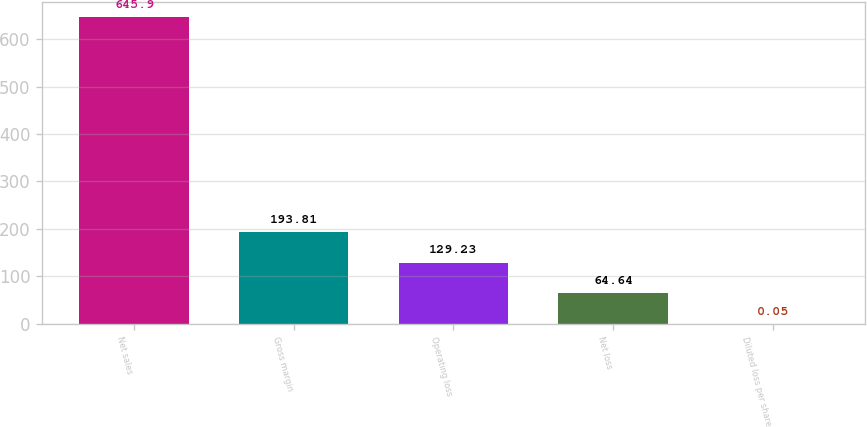Convert chart. <chart><loc_0><loc_0><loc_500><loc_500><bar_chart><fcel>Net sales<fcel>Gross margin<fcel>Operating loss<fcel>Net loss<fcel>Diluted loss per share<nl><fcel>645.9<fcel>193.81<fcel>129.23<fcel>64.64<fcel>0.05<nl></chart> 